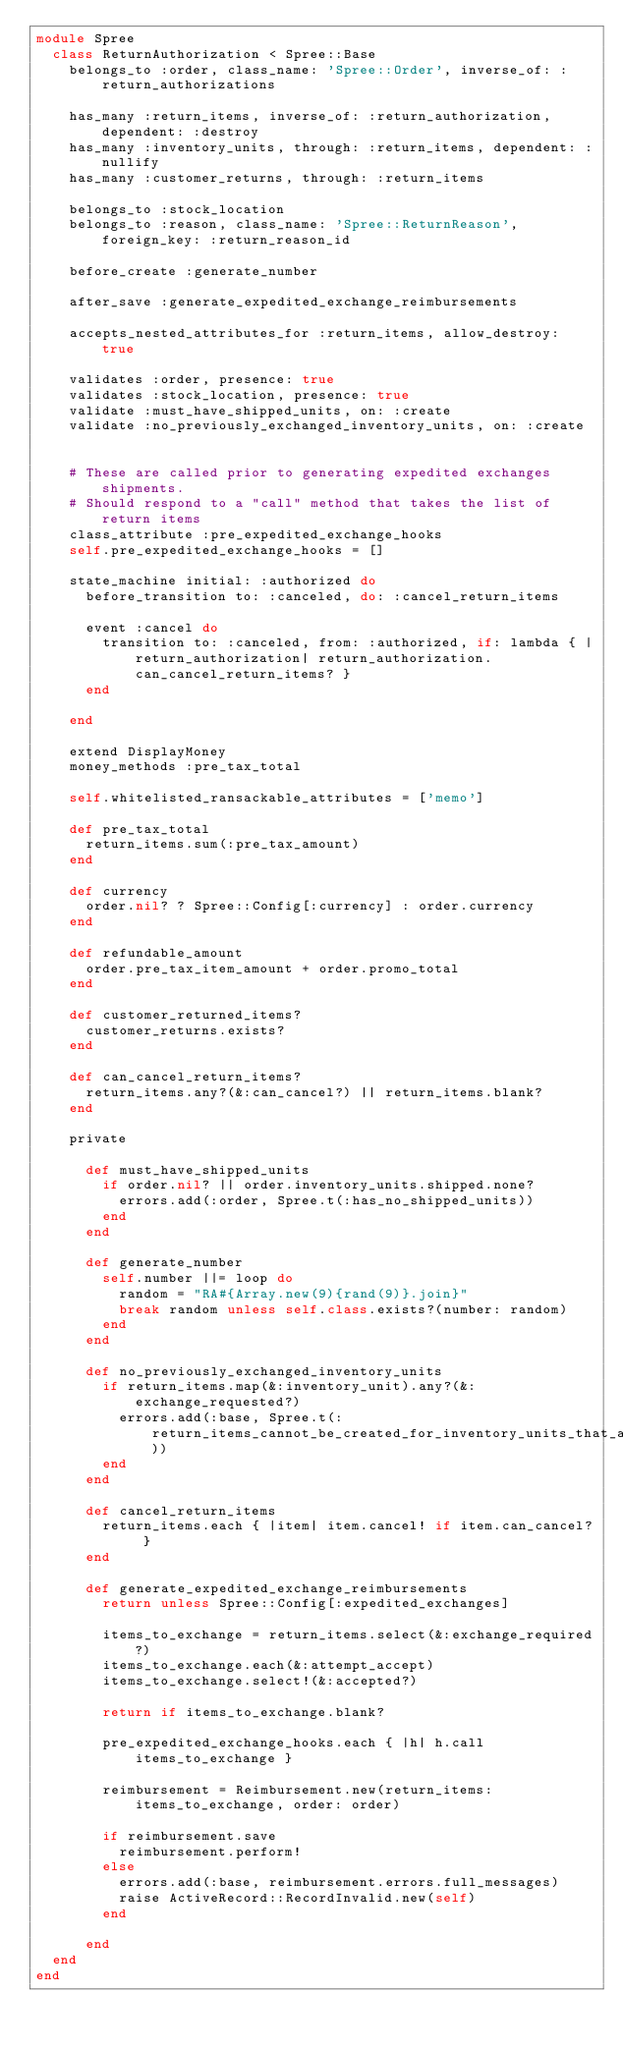Convert code to text. <code><loc_0><loc_0><loc_500><loc_500><_Ruby_>module Spree
  class ReturnAuthorization < Spree::Base
    belongs_to :order, class_name: 'Spree::Order', inverse_of: :return_authorizations

    has_many :return_items, inverse_of: :return_authorization, dependent: :destroy
    has_many :inventory_units, through: :return_items, dependent: :nullify
    has_many :customer_returns, through: :return_items

    belongs_to :stock_location
    belongs_to :reason, class_name: 'Spree::ReturnReason', foreign_key: :return_reason_id

    before_create :generate_number

    after_save :generate_expedited_exchange_reimbursements

    accepts_nested_attributes_for :return_items, allow_destroy: true

    validates :order, presence: true
    validates :stock_location, presence: true
    validate :must_have_shipped_units, on: :create
    validate :no_previously_exchanged_inventory_units, on: :create


    # These are called prior to generating expedited exchanges shipments.
    # Should respond to a "call" method that takes the list of return items
    class_attribute :pre_expedited_exchange_hooks
    self.pre_expedited_exchange_hooks = []

    state_machine initial: :authorized do
      before_transition to: :canceled, do: :cancel_return_items

      event :cancel do
        transition to: :canceled, from: :authorized, if: lambda { |return_authorization| return_authorization.can_cancel_return_items? }
      end

    end

    extend DisplayMoney
    money_methods :pre_tax_total

    self.whitelisted_ransackable_attributes = ['memo']

    def pre_tax_total
      return_items.sum(:pre_tax_amount)
    end

    def currency
      order.nil? ? Spree::Config[:currency] : order.currency
    end

    def refundable_amount
      order.pre_tax_item_amount + order.promo_total
    end

    def customer_returned_items?
      customer_returns.exists?
    end

    def can_cancel_return_items?
      return_items.any?(&:can_cancel?) || return_items.blank?
    end

    private

      def must_have_shipped_units
        if order.nil? || order.inventory_units.shipped.none?
          errors.add(:order, Spree.t(:has_no_shipped_units))
        end
      end

      def generate_number
        self.number ||= loop do
          random = "RA#{Array.new(9){rand(9)}.join}"
          break random unless self.class.exists?(number: random)
        end
      end

      def no_previously_exchanged_inventory_units
        if return_items.map(&:inventory_unit).any?(&:exchange_requested?)
          errors.add(:base, Spree.t(:return_items_cannot_be_created_for_inventory_units_that_are_already_awaiting_exchange))
        end
      end

      def cancel_return_items
        return_items.each { |item| item.cancel! if item.can_cancel? }
      end

      def generate_expedited_exchange_reimbursements
        return unless Spree::Config[:expedited_exchanges]

        items_to_exchange = return_items.select(&:exchange_required?)
        items_to_exchange.each(&:attempt_accept)
        items_to_exchange.select!(&:accepted?)

        return if items_to_exchange.blank?

        pre_expedited_exchange_hooks.each { |h| h.call items_to_exchange }

        reimbursement = Reimbursement.new(return_items: items_to_exchange, order: order)

        if reimbursement.save
          reimbursement.perform!
        else
          errors.add(:base, reimbursement.errors.full_messages)
          raise ActiveRecord::RecordInvalid.new(self)
        end

      end
  end
end
</code> 